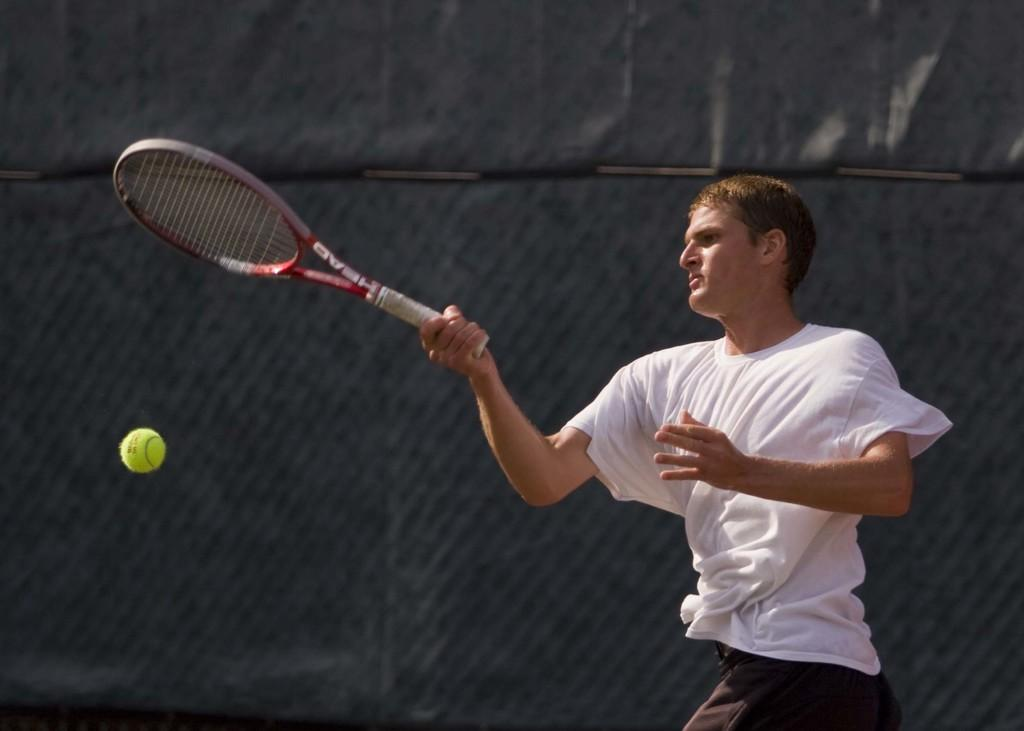What is the main subject of the image? The main subject of the image is a man standing. What is the man wearing in the image? The man is wearing clothes in the image. What object is the man holding in his hand? The man is holding a tennis bat in his hand. What other tennis-related object can be seen in the image? There is a tennis ball in the image. How would you describe the background of the image? The background of the image is dark. What type of boundary is visible in the image? There is no boundary visible in the image; it features a man standing with a tennis bat and a tennis ball. What process is being demonstrated in the image? The image does not depict a process; it shows a man holding a tennis bat and standing near a tennis ball. 